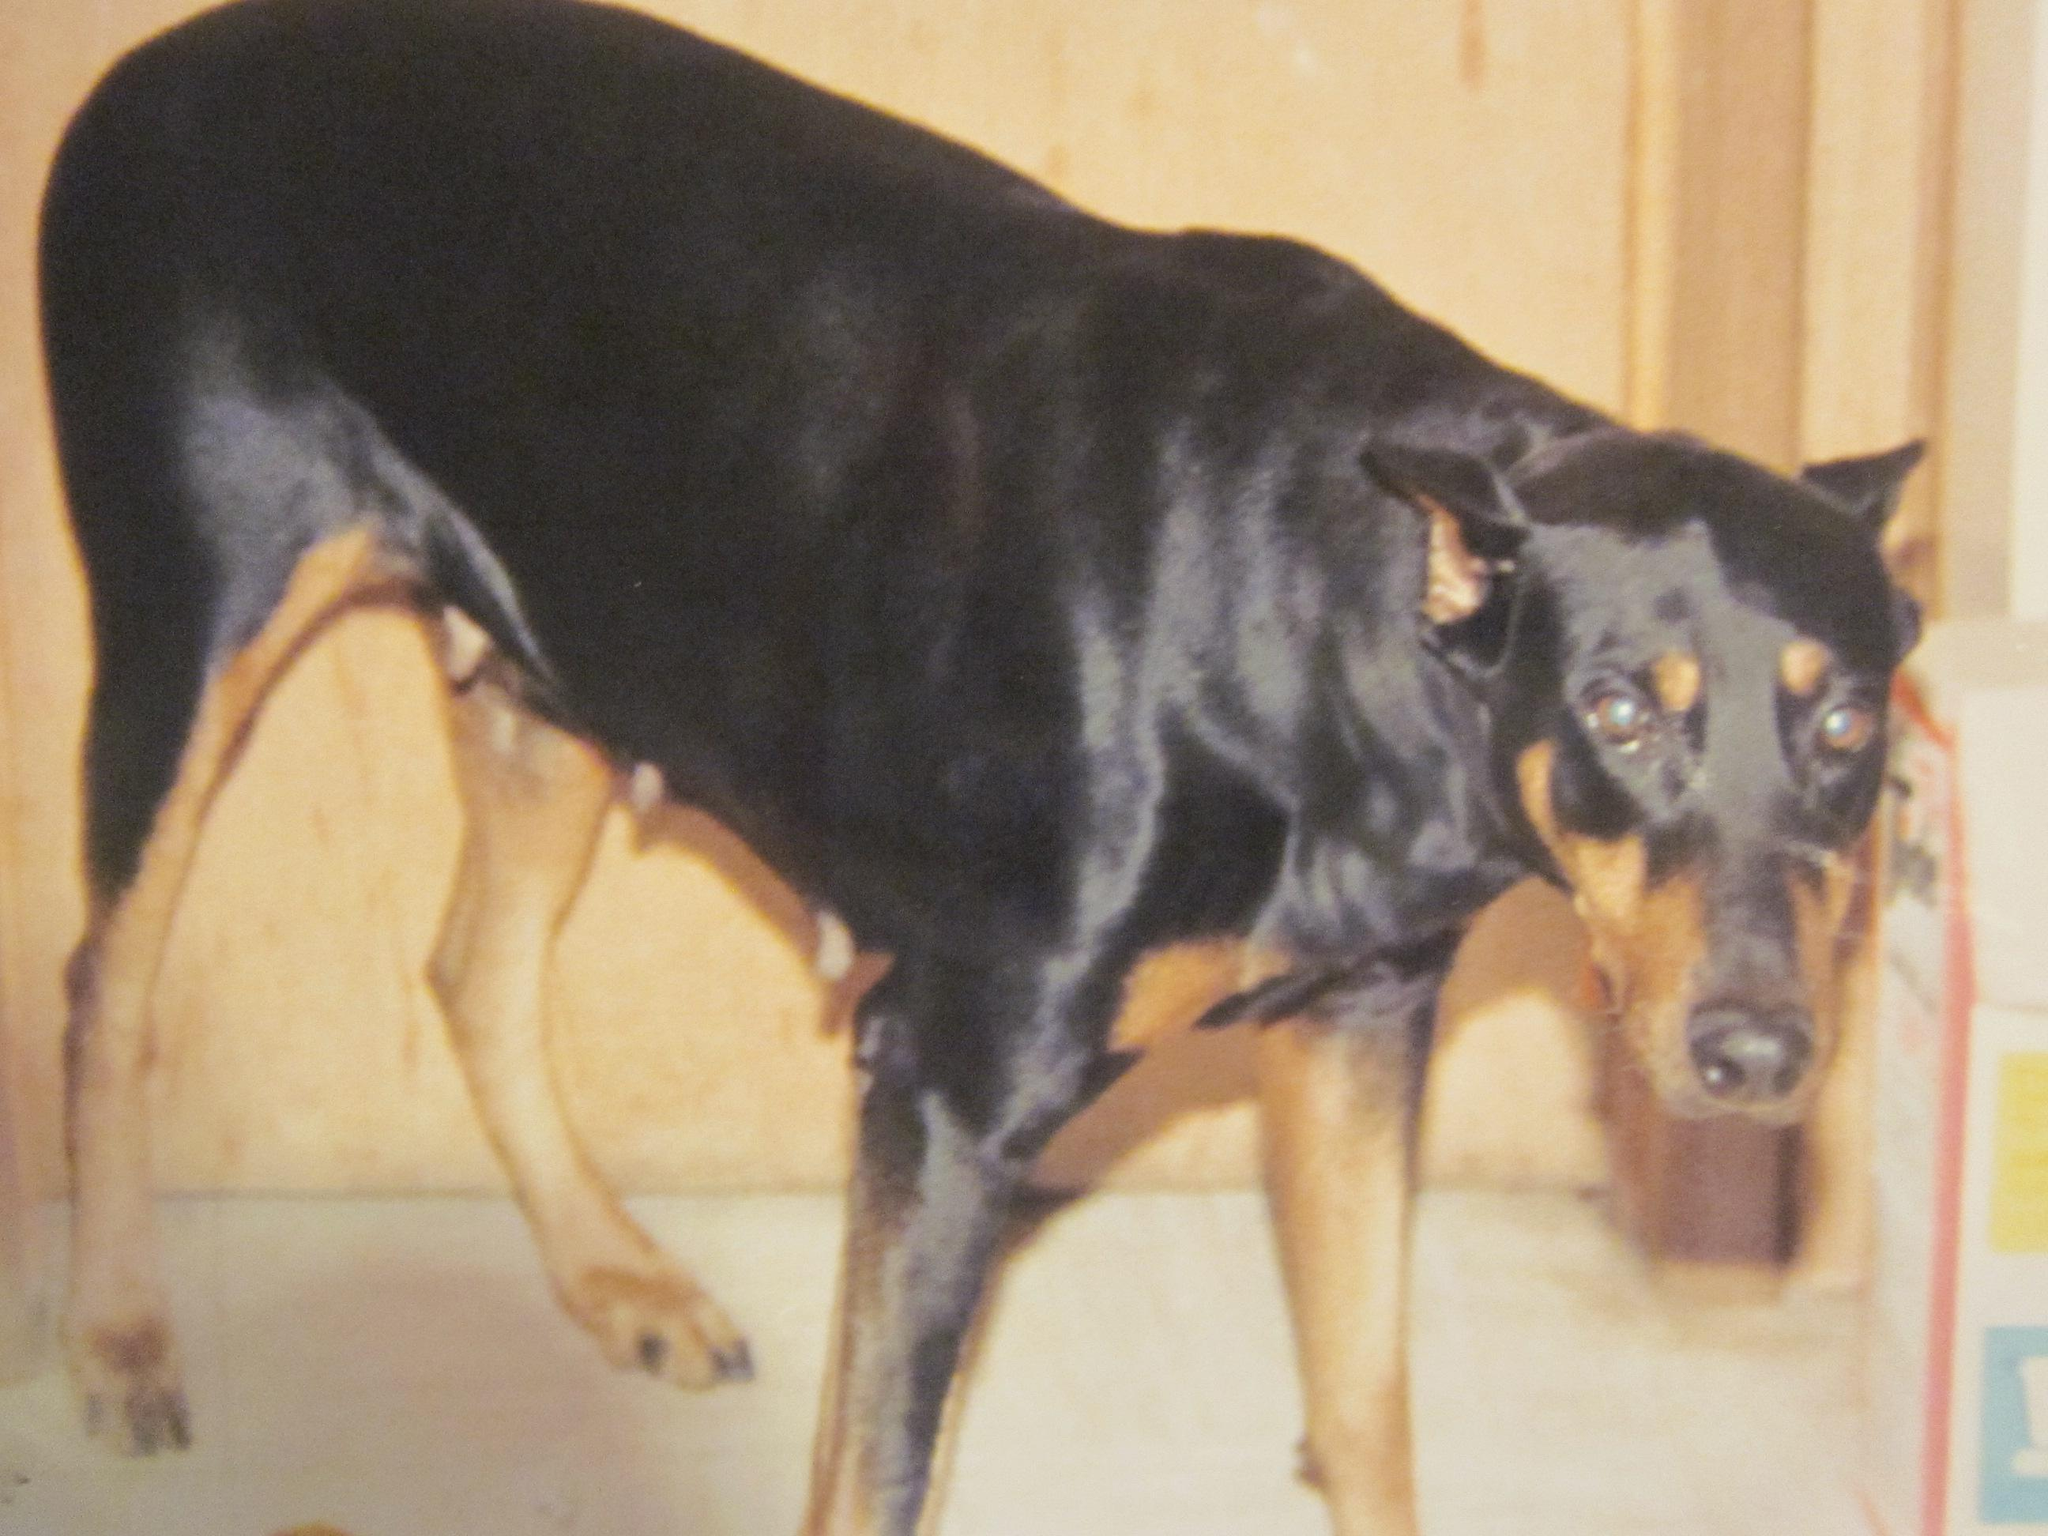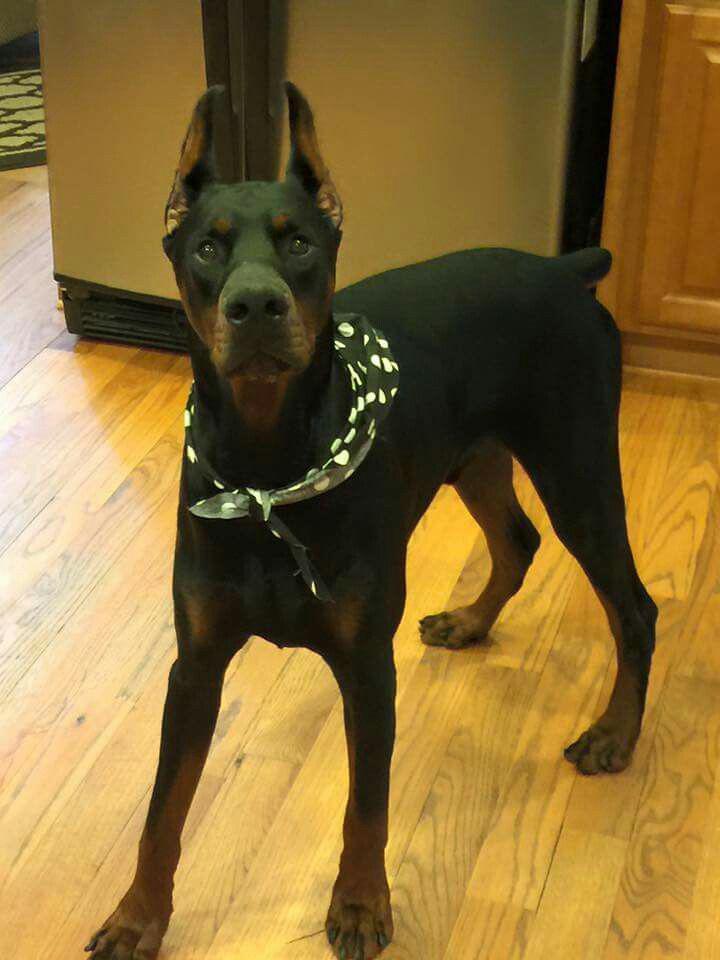The first image is the image on the left, the second image is the image on the right. Given the left and right images, does the statement "The right image contains a black and brown dog inside on a wooden floor." hold true? Answer yes or no. Yes. The first image is the image on the left, the second image is the image on the right. Considering the images on both sides, is "Both dogs are indoors." valid? Answer yes or no. Yes. 